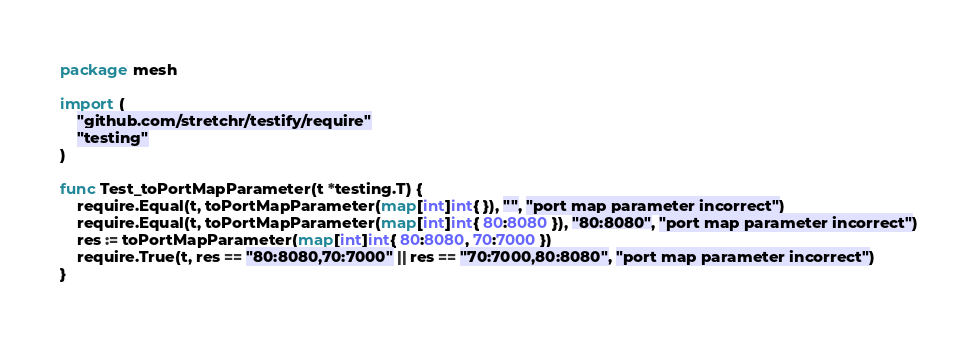<code> <loc_0><loc_0><loc_500><loc_500><_Go_>package mesh

import (
	"github.com/stretchr/testify/require"
	"testing"
)

func Test_toPortMapParameter(t *testing.T) {
	require.Equal(t, toPortMapParameter(map[int]int{ }), "", "port map parameter incorrect")
	require.Equal(t, toPortMapParameter(map[int]int{ 80:8080 }), "80:8080", "port map parameter incorrect")
	res := toPortMapParameter(map[int]int{ 80:8080, 70:7000 })
	require.True(t, res == "80:8080,70:7000" || res == "70:7000,80:8080", "port map parameter incorrect")
}
</code> 